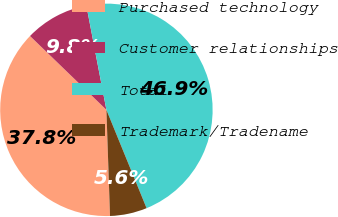Convert chart to OTSL. <chart><loc_0><loc_0><loc_500><loc_500><pie_chart><fcel>Purchased technology<fcel>Customer relationships<fcel>Total<fcel>Trademark/Tradename<nl><fcel>37.77%<fcel>9.75%<fcel>46.85%<fcel>5.63%<nl></chart> 